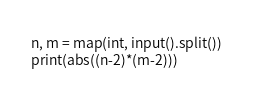<code> <loc_0><loc_0><loc_500><loc_500><_Python_>n, m = map(int, input().split())
print(abs((n-2)*(m-2)))</code> 